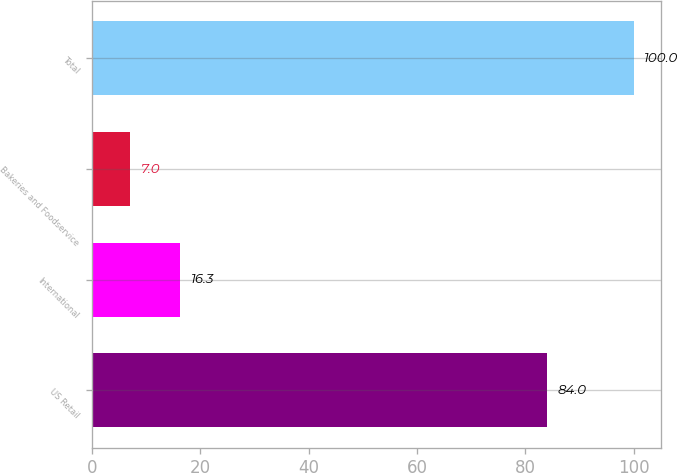Convert chart to OTSL. <chart><loc_0><loc_0><loc_500><loc_500><bar_chart><fcel>US Retail<fcel>International<fcel>Bakeries and Foodservice<fcel>Total<nl><fcel>84<fcel>16.3<fcel>7<fcel>100<nl></chart> 